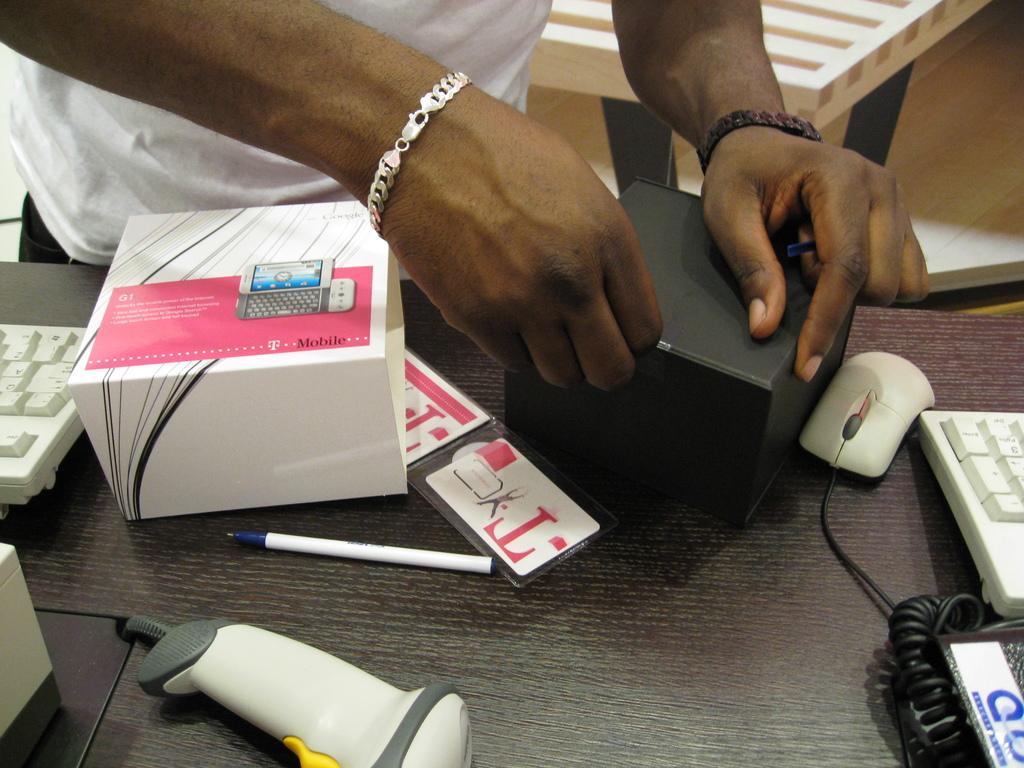Describe this image in one or two sentences. In this image I see person's hand and there are two boxes, a pen, a mouse, two keyboards and other things on the table and I can also see this person is wearing a white t-shirt. 